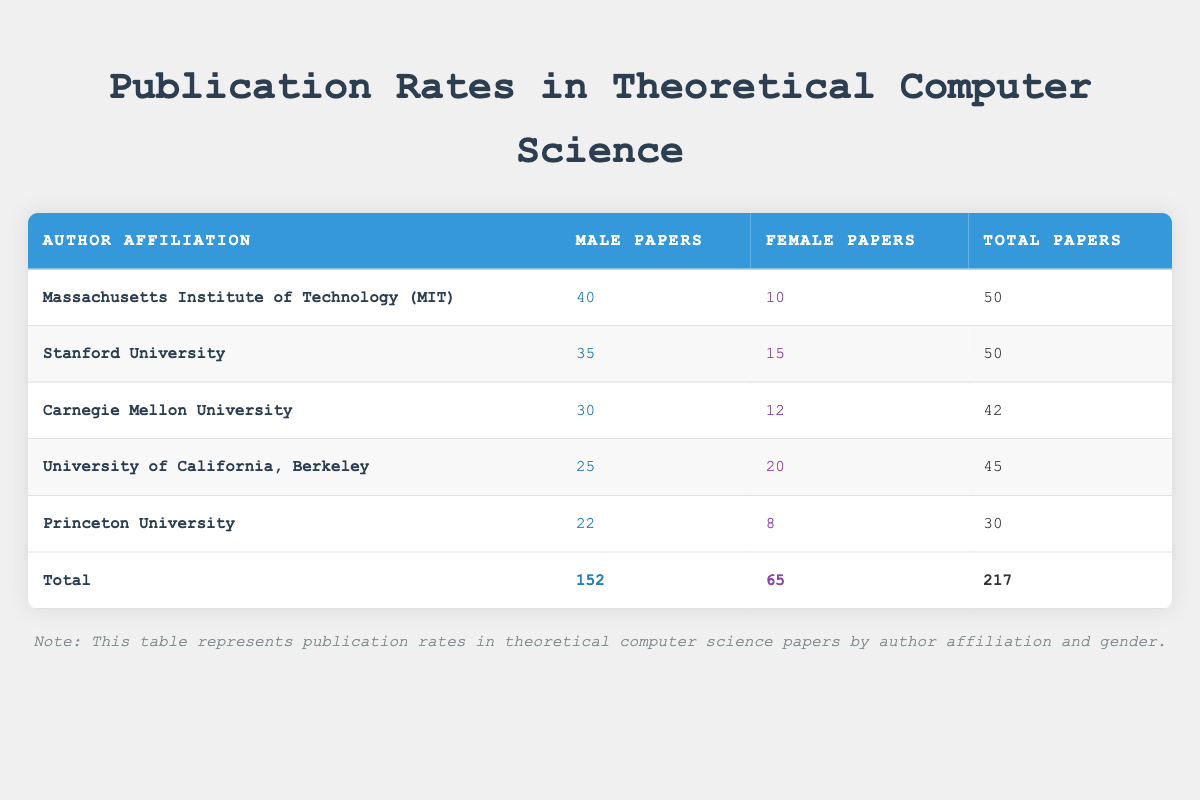What is the total number of papers published by authors from Stanford University? From the table, we can directly see the number of papers published by male authors from Stanford University is 35 and by female authors is 15. Adding them together gives us 35 + 15 = 50.
Answer: 50 How many papers did female authors publish in total across all affiliations? By examining the table, we can sum the publications of female authors: 10 (MIT) + 15 (Stanford) + 12 (Carnegie Mellon) + 20 (UC Berkeley) + 8 (Princeton) = 65.
Answer: 65 Did the Massachusetts Institute of Technology have more papers published by male or female authors? The table shows that MIT had 40 papers published by male authors and 10 by female authors. Since 40 is greater than 10, the answer is yes.
Answer: Yes What is the difference in the number of papers published by male authors between MIT and Carnegie Mellon University? For MIT, male publications are 40 and for Carnegie Mellon, they are 30. The difference can be calculated as 40 - 30 = 10.
Answer: 10 Which university had the highest number of papers published by female authors? Looking through the table, we see: MIT had 10, Stanford had 15, Carnegie Mellon had 12, UC Berkeley had 20, and Princeton had 8. The highest is 20 from UC Berkeley.
Answer: UC Berkeley What is the average number of papers published by male authors across all institutions? The total number of papers published by male authors is 152 (sum from the table). There are 5 institutions, so the average is 152 / 5 = 30.4.
Answer: 30.4 Is it true that Princeton University had equal or more total publications compared to Carnegie Mellon University? Princeton had 30 total publications and Carnegie Mellon had 42. Comparing the two, 30 is less than 42, so the statement is false.
Answer: No What is the total number of papers published by both genders at UC Berkeley? For UC Berkeley, the table reports 25 papers published by males and 20 by females. Adding these, we get 25 + 20 = 45 total papers published.
Answer: 45 What is the ratio of male to female papers published at Stanford University? The table indicates 35 male papers and 15 female papers published at Stanford. The ratio can be calculated as 35:15, which simplifies to 7:3.
Answer: 7:3 